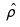Convert formula to latex. <formula><loc_0><loc_0><loc_500><loc_500>\hat { \rho }</formula> 